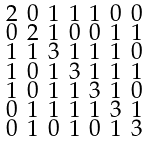Convert formula to latex. <formula><loc_0><loc_0><loc_500><loc_500>\begin{smallmatrix} 2 & 0 & 1 & 1 & 1 & 0 & 0 \\ 0 & 2 & 1 & 0 & 0 & 1 & 1 \\ 1 & 1 & 3 & 1 & 1 & 1 & 0 \\ 1 & 0 & 1 & 3 & 1 & 1 & 1 \\ 1 & 0 & 1 & 1 & 3 & 1 & 0 \\ 0 & 1 & 1 & 1 & 1 & 3 & 1 \\ 0 & 1 & 0 & 1 & 0 & 1 & 3 \end{smallmatrix}</formula> 